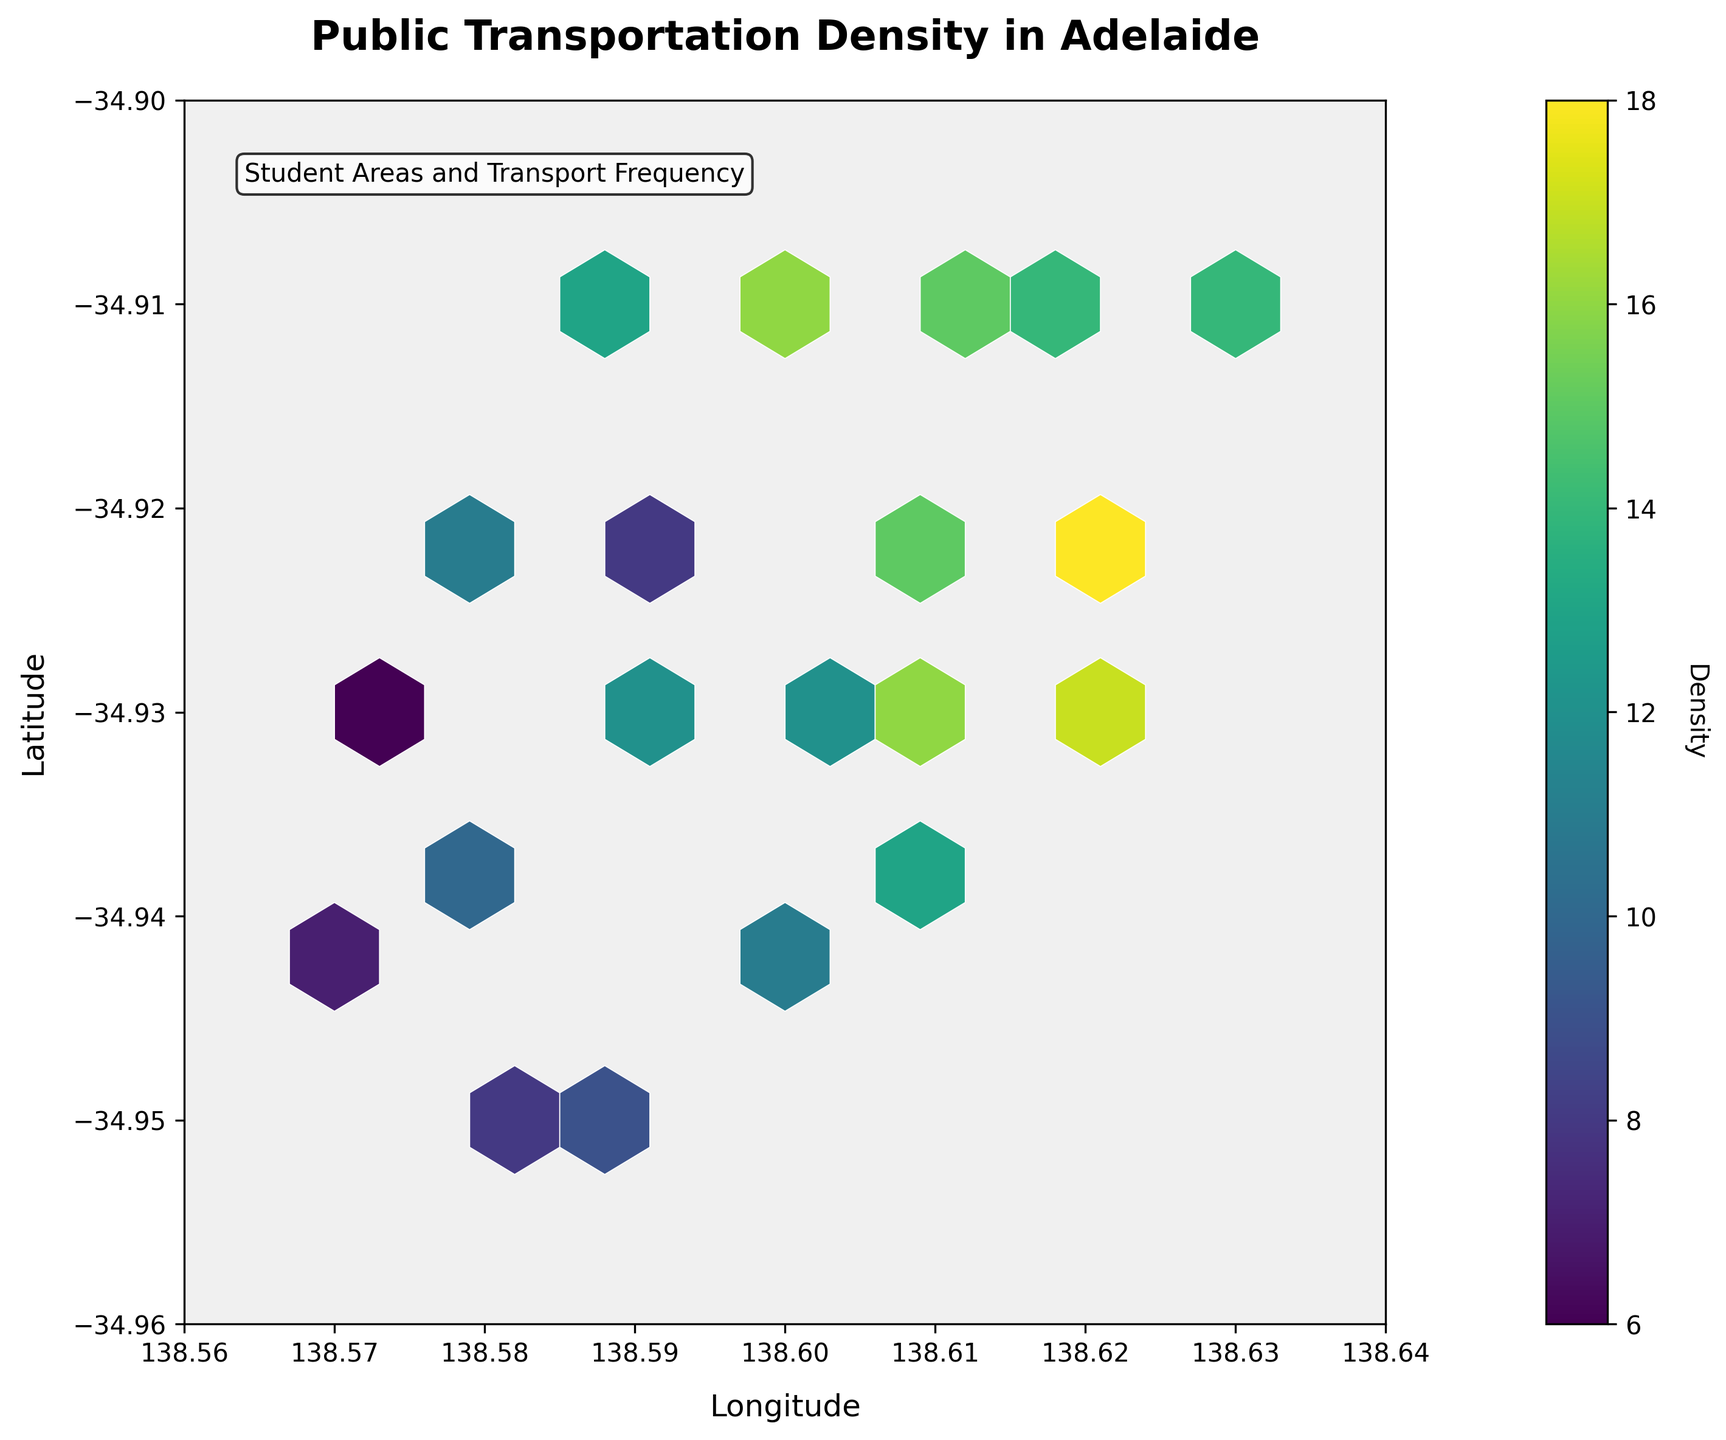How is the density of public transportation options represented in the figure? The density of public transportation options is represented by the color intensity in the hexagonal bins, where darker colors indicate higher density and lighter colors indicate lower density.
Answer: By color intensity in hexagonal bins What is the title of the figure? The title of the figure is "Public Transportation Density in Adelaide". This information is located at the top of the figure.
Answer: Public Transportation Density in Adelaide Which coordinate range for longitude and latitude does the plot cover? The x-axis covers longitudes from 138.56 to 138.64, and the y-axis covers latitudes from -34.96 to -34.90. This information is shown on the axis labels.
Answer: 138.56 to 138.64 for longitude and -34.96 to -34.90 for latitude Which area has the highest density of public transportation options? The highest density of public transportation options is indicated by the darkest color on the plot, which corresponds to a frequency and proximity around longitude 138.62 and latitude -34.92.
Answer: Around longitude 138.62 and latitude -34.92 What does the color bar represent? The color bar represents the density of public transportation options, with varying shades from lighter to darker indicating lower to higher density respectively. This information is shown as "Density" on the color bar label.
Answer: Density Where are the areas with the lowest density of public transportation options located? The areas with the lowest density of public transportation options are shown in the lightest color in the hexagonal bins, which are primarily located near the borders of the plot, particularly around longitude 138.57 and latitude -34.95.
Answer: Around longitude 138.57 and latitude -34.95 How does the density of public transportation options change as you move from longitude 138.58 to 138.62 at latitude -34.93? The density increases as indicated by darker colors around longitudes 138.60 to 138.62 compared to 138.58 at the same latitude. This is observed by moving horizontally from left to right.
Answer: Density increases Which area between longitude 138.59 and 138.61 at latitude -34.92 has the higher density of public transportation options? The area near longitude 138.61 has a higher density compared to 138.59 at the same latitude as indicated by a darker color.
Answer: Longitude 138.61 What does the white and light cream color of the background of the hexbin plot indicate? The white and light cream color of the background represents areas outside the hexagonal bins where no or very low data on public transportation options are available.
Answer: Areas outside hexagonal bins with low or no data 